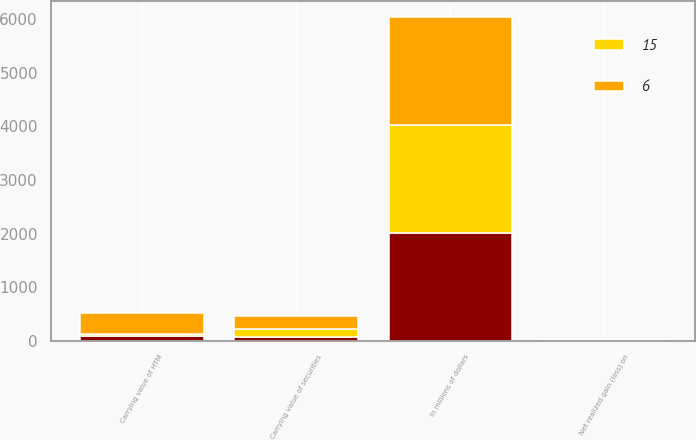Convert chart to OTSL. <chart><loc_0><loc_0><loc_500><loc_500><stacked_bar_chart><ecel><fcel>In millions of dollars<fcel>Carrying value of HTM<fcel>Net realized gain (loss) on<fcel>Carrying value of securities<nl><fcel>nan<fcel>2017<fcel>81<fcel>13<fcel>74<nl><fcel>15<fcel>2016<fcel>49<fcel>14<fcel>150<nl><fcel>6<fcel>2015<fcel>392<fcel>10<fcel>243<nl></chart> 